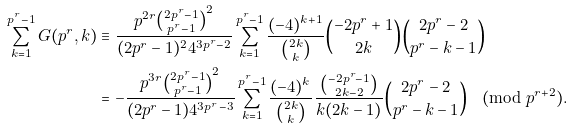Convert formula to latex. <formula><loc_0><loc_0><loc_500><loc_500>\sum _ { k = 1 } ^ { p ^ { r } - 1 } G ( p ^ { r } , k ) & \equiv \frac { p ^ { 2 r } \binom { 2 p ^ { r } - 1 } { p ^ { r } - 1 } ^ { 2 } } { ( 2 p ^ { r } - 1 ) ^ { 2 } 4 ^ { 3 p ^ { r } - 2 } } \sum _ { k = 1 } ^ { p ^ { r } - 1 } \frac { ( - 4 ) ^ { k + 1 } } { \binom { 2 k } { k } } \binom { - 2 p ^ { r } + 1 } { 2 k } \binom { 2 p ^ { r } - 2 } { p ^ { r } - k - 1 } \\ & = - \frac { p ^ { 3 r } \binom { 2 p ^ { r } - 1 } { p ^ { r } - 1 } ^ { 2 } } { ( 2 p ^ { r } - 1 ) 4 ^ { 3 p ^ { r } - 3 } } \sum _ { k = 1 } ^ { p ^ { r } - 1 } \frac { ( - 4 ) ^ { k } } { \binom { 2 k } { k } } \frac { \binom { - 2 p ^ { r } - 1 } { 2 k - 2 } } { k ( 2 k - 1 ) } \binom { 2 p ^ { r } - 2 } { p ^ { r } - k - 1 } \pmod { p ^ { r + 2 } } .</formula> 